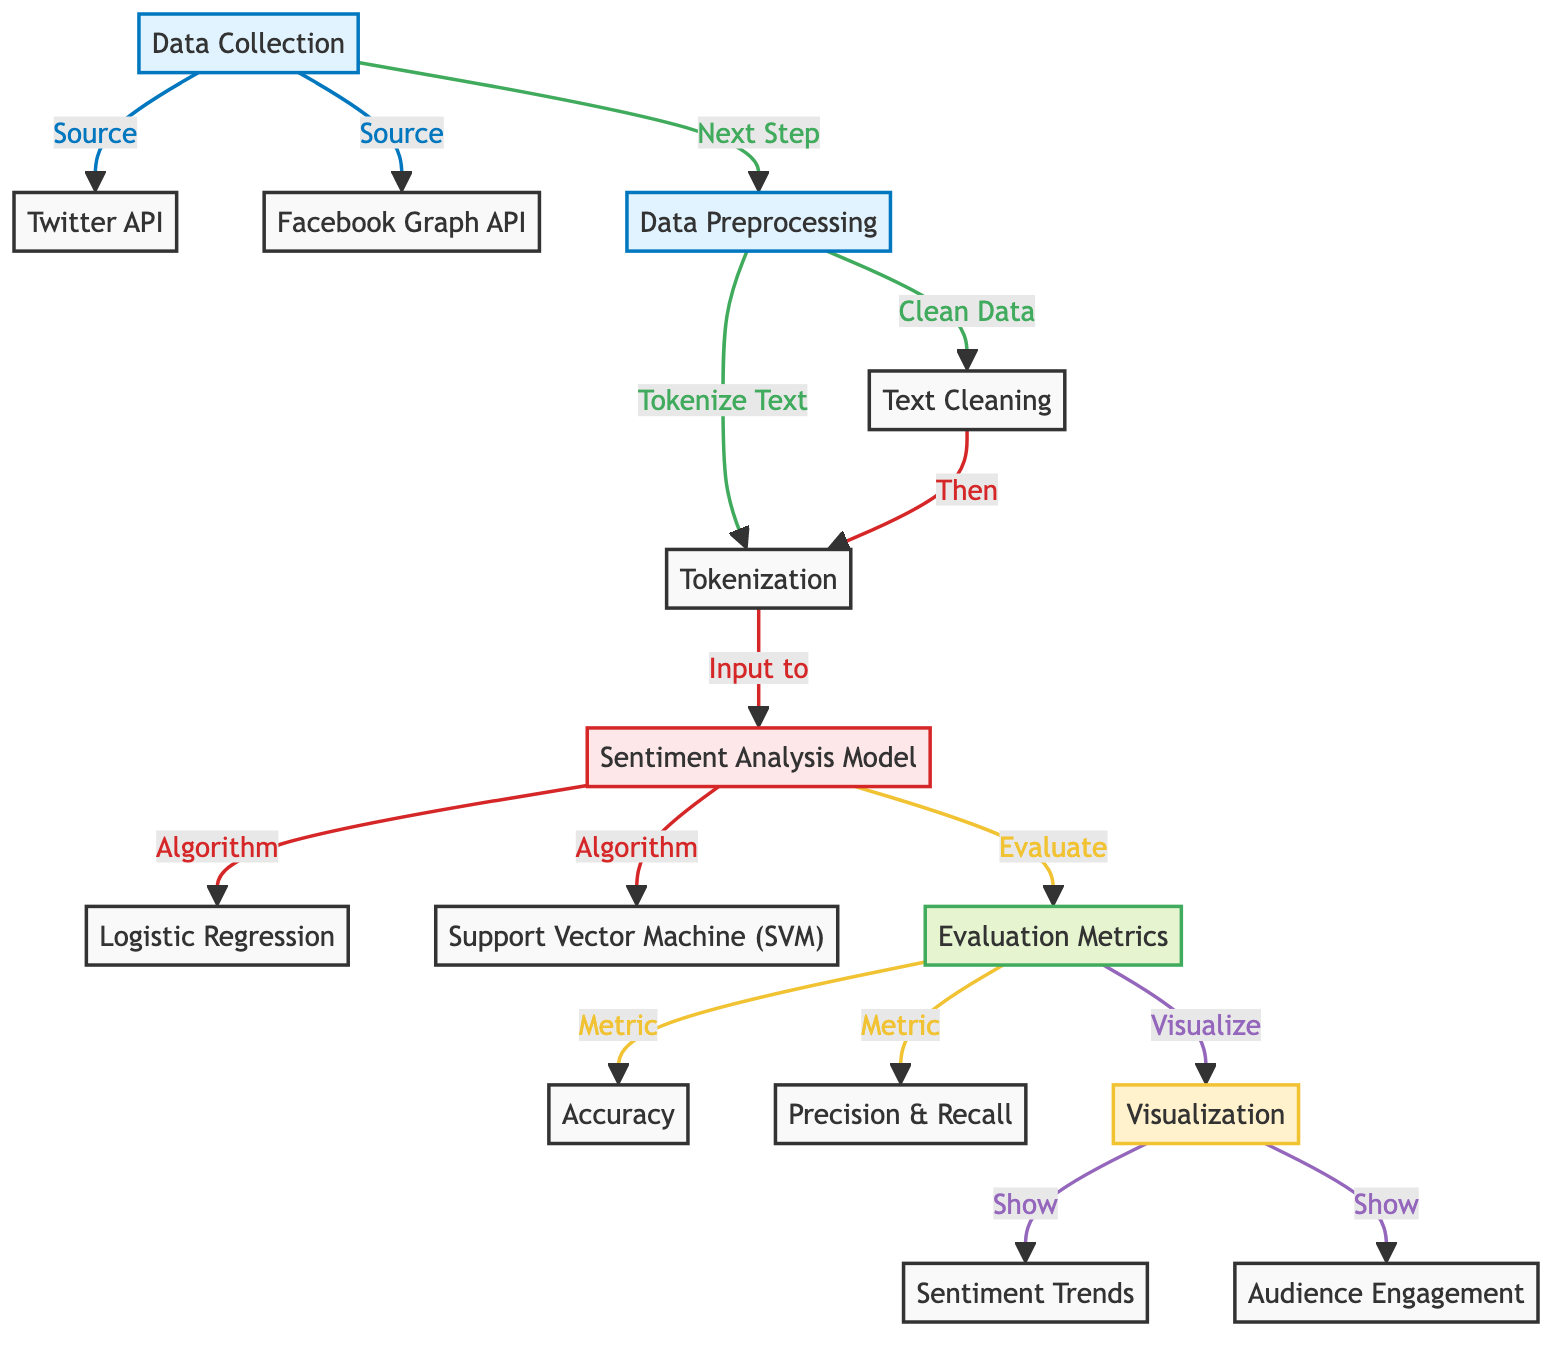What are the two sources of data collection in the diagram? The diagram lists two sources under the "Data Collection" node: "Twitter API" and "Facebook Graph API". These are the platforms from which data is sourced.
Answer: Twitter API, Facebook Graph API How many algorithms are used in the sentiment analysis model? The sentiment analysis model in the diagram mentions two algorithms: "Logistic Regression" and "Support Vector Machine (SVM)". This counts as two separate algorithms utilized in analysis.
Answer: 2 Which step comes after text cleaning in the data preprocessing phase? In the diagram, after the "Text Cleaning" step, the next step is "Tokenization". This is how the data flows in the preprocessing phase.
Answer: Tokenization What is evaluated in the evaluation metrics section? The evaluation metrics section includes two main aspects that are evaluated: "Accuracy" and "Precision & Recall". These are key performance metrics for the model.
Answer: Accuracy, Precision & Recall What type of visualization does the diagram output in the end? The visualization section outputs two specific visualizations: "Sentiment Trends" and "Audience Engagement". These visual representations summarize the results from the analysis.
Answer: Sentiment Trends, Audience Engagement Which step inputs data into the sentiment analysis model? The "Tokenization" step inputs processed text data into the "Sentiment Analysis Model". This step is crucial for preparing data for sentiment analysis.
Answer: Tokenization What links are shown for the data preprocessing process? The links for the data preprocessing process indicate that data collection leads to several steps: "Text Cleaning" and "Tokenization". It shows the flow of data processing next.
Answer: Text Cleaning, Tokenization How many metrics are visualized after evaluation metrics? After the evaluation metrics, two areas are visualized: "Sentiment Trends" and "Audience Engagement". These visualize the outcomes of the evaluation stage.
Answer: 2 